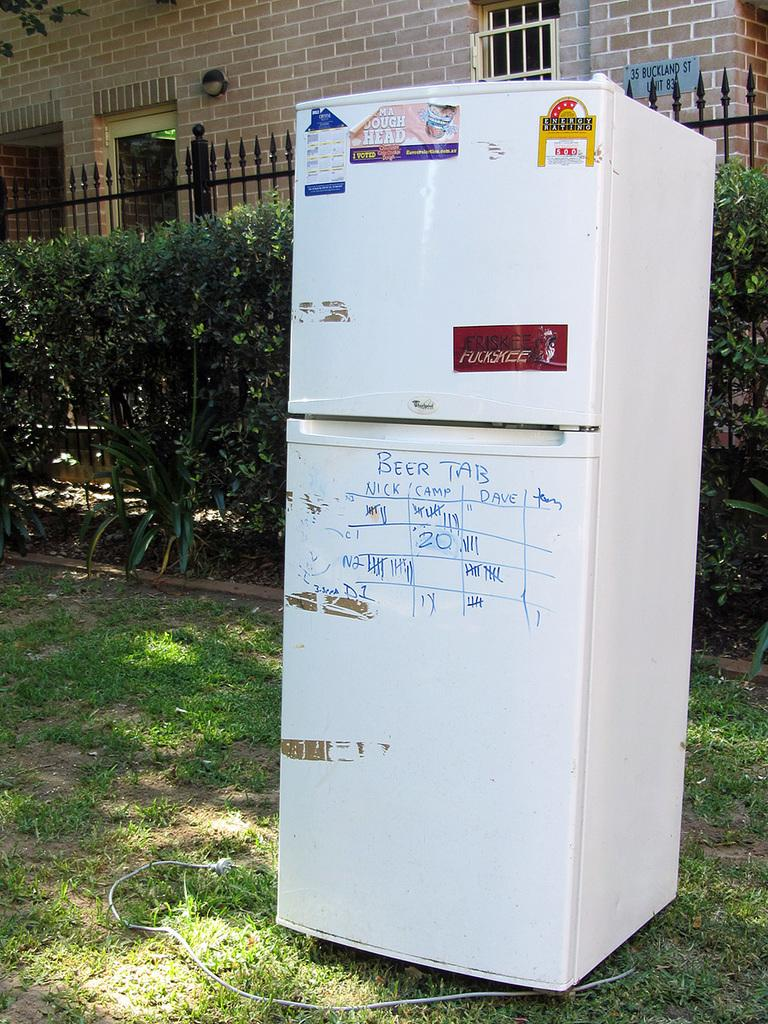What type of appliance is visible in the image? There is a white fridge in the image. What is located behind the fridge? There are plants behind the fridge. What type of barrier can be seen in the image? There is fencing visible in the image. What is in the background of the image? There is a wall in the background of the image. What type of vegetation is present on the land in the image? Grass is present on the land in the image. What type of beast can be seen roaming in the front of the fridge in the image? There is no beast present in the image; it only features a white fridge, plants, fencing, a wall, and grass. 